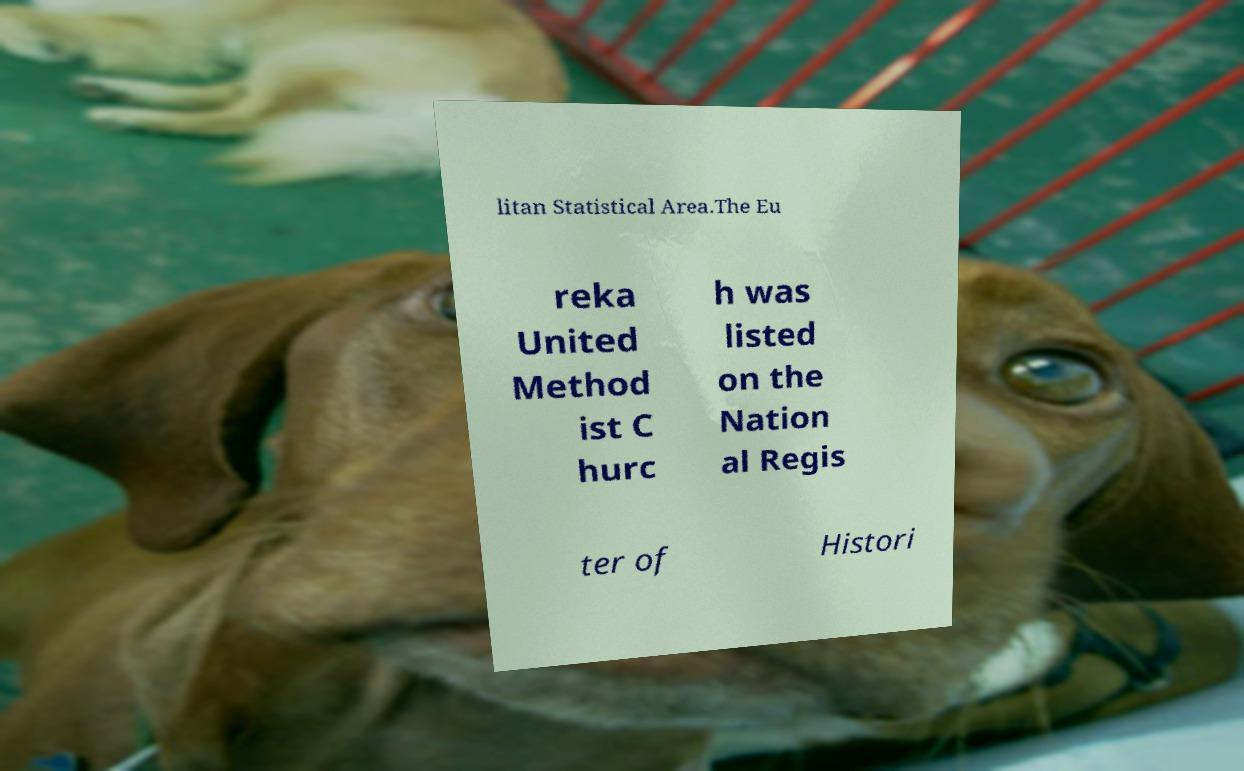For documentation purposes, I need the text within this image transcribed. Could you provide that? litan Statistical Area.The Eu reka United Method ist C hurc h was listed on the Nation al Regis ter of Histori 